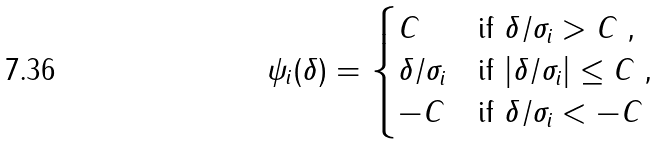<formula> <loc_0><loc_0><loc_500><loc_500>\psi _ { i } ( \delta ) = \begin{cases} C & \text {if $\delta/\sigma_{i}>C$ ,} \\ \delta / \sigma _ { i } & \text {if $|\delta/\sigma_{i}|\leq C$ ,} \\ - C & \text {if $\delta/\sigma_{i}<-C$} \end{cases}</formula> 